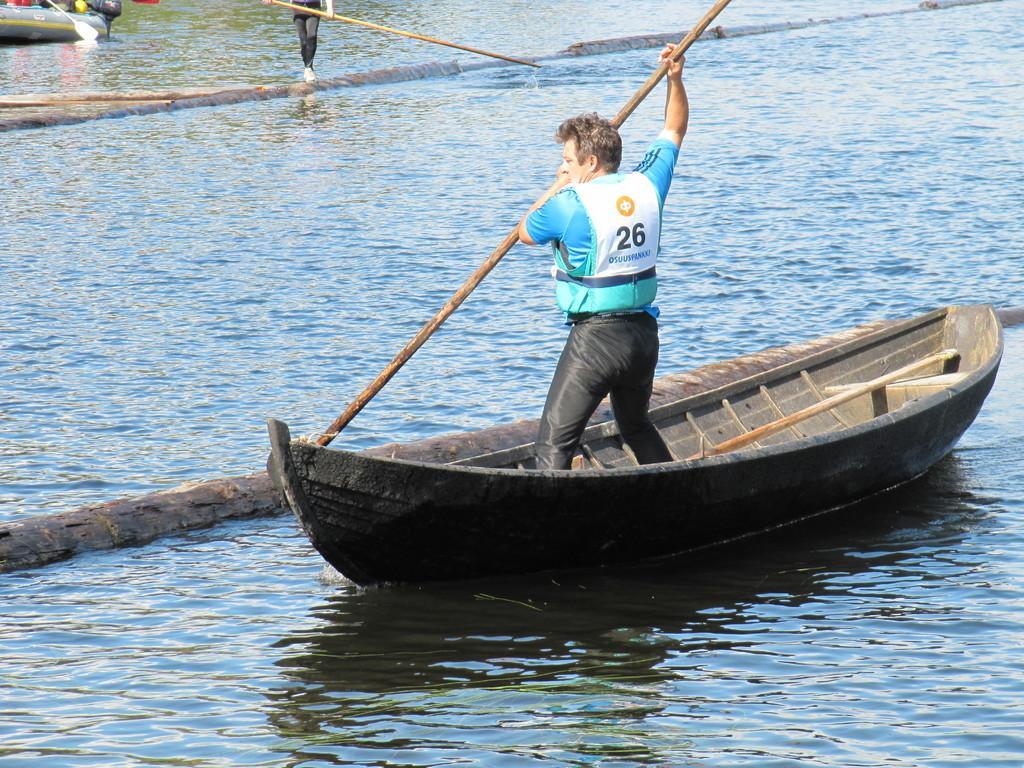Describe this image in one or two sentences. This image is taken outdoors. At the bottom of the image there is a river with water. In the middle of the image a man is standing in the boat and he is holding a stick in his hand. At the top of the image there is another boat and there is a person holding a stick in the hand. 